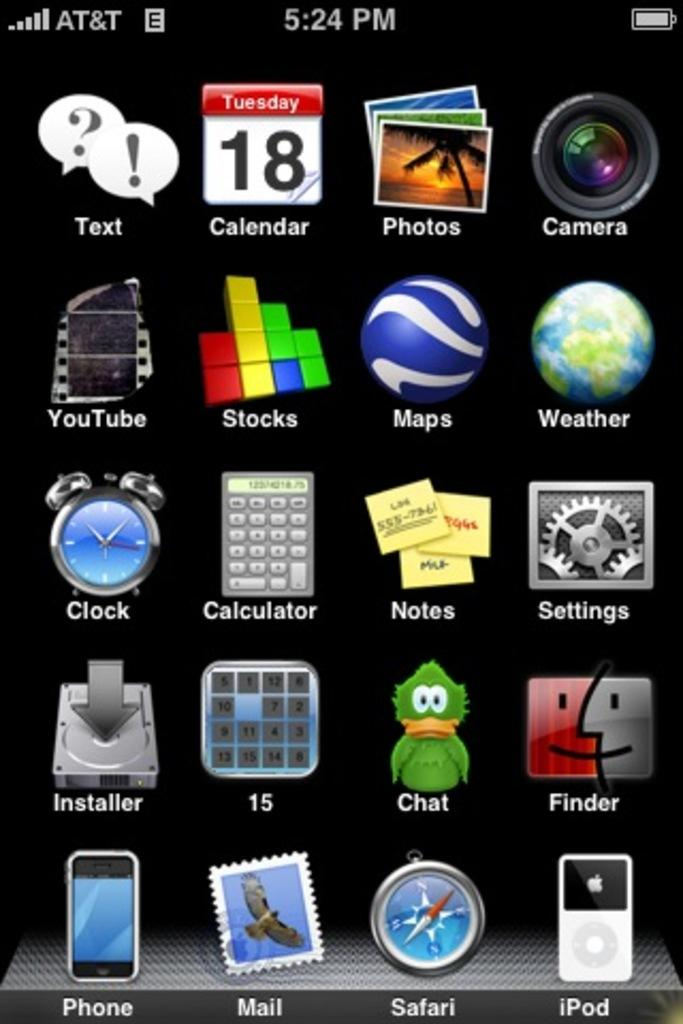<image>
Give a short and clear explanation of the subsequent image. A phone screen has icons for Youtube and Clock, amongst other things. 